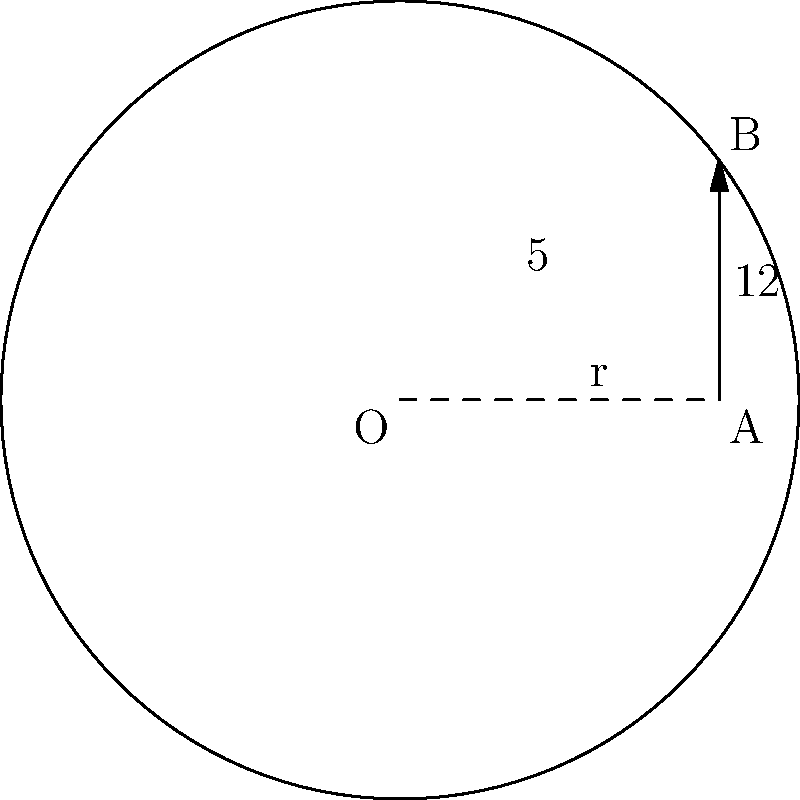In the diagram, $O$ is the center of the circle, $AB$ is a tangent line to the circle at point $A$, and $OB$ is perpendicular to $AB$. Given that $AB = 12$ and $OA = 5$, calculate the radius $r$ of the circle. Let's approach this step-by-step using the Pythagorean theorem:

1) In the right-angled triangle $OAB$:
   $OA$ is the radius (let's call it $r$)
   $AB$ is the tangent line (given as 12)
   $OB$ is the hypotenuse

2) By the Pythagorean theorem:
   $OA^2 + AB^2 = OB^2$

3) Substitute the known values:
   $5^2 + 12^2 = OB^2$

4) Simplify:
   $25 + 144 = OB^2$
   $169 = OB^2$

5) Take the square root of both sides:
   $\sqrt{169} = OB$
   $13 = OB$

6) Now we know that $OB = 13$ and $OA = 5$

7) The radius $r$ is equal to $OA$, which is given as 5.

Therefore, the radius of the circle is 5.
Answer: $r = 5$ 